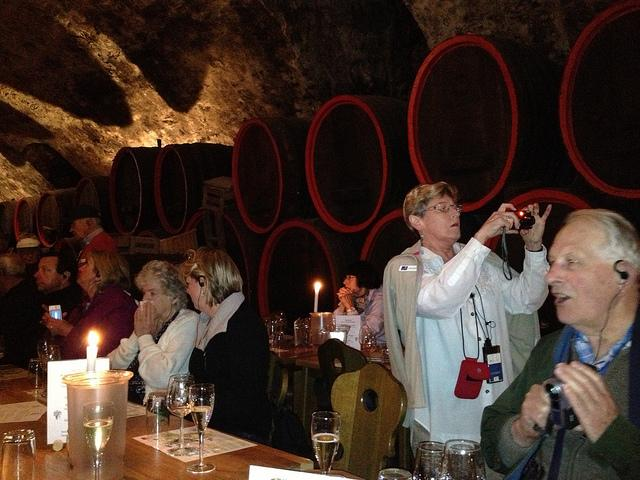What would most likely be stored in this type of location? wine 